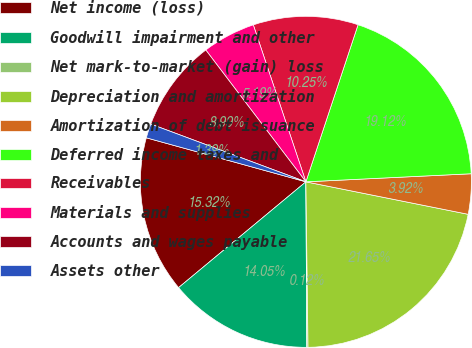<chart> <loc_0><loc_0><loc_500><loc_500><pie_chart><fcel>Net income (loss)<fcel>Goodwill impairment and other<fcel>Net mark-to-market (gain) loss<fcel>Depreciation and amortization<fcel>Amortization of debt issuance<fcel>Deferred income taxes and<fcel>Receivables<fcel>Materials and supplies<fcel>Accounts and wages payable<fcel>Assets other<nl><fcel>15.32%<fcel>14.05%<fcel>0.12%<fcel>21.65%<fcel>3.92%<fcel>19.12%<fcel>10.25%<fcel>5.19%<fcel>8.99%<fcel>1.39%<nl></chart> 